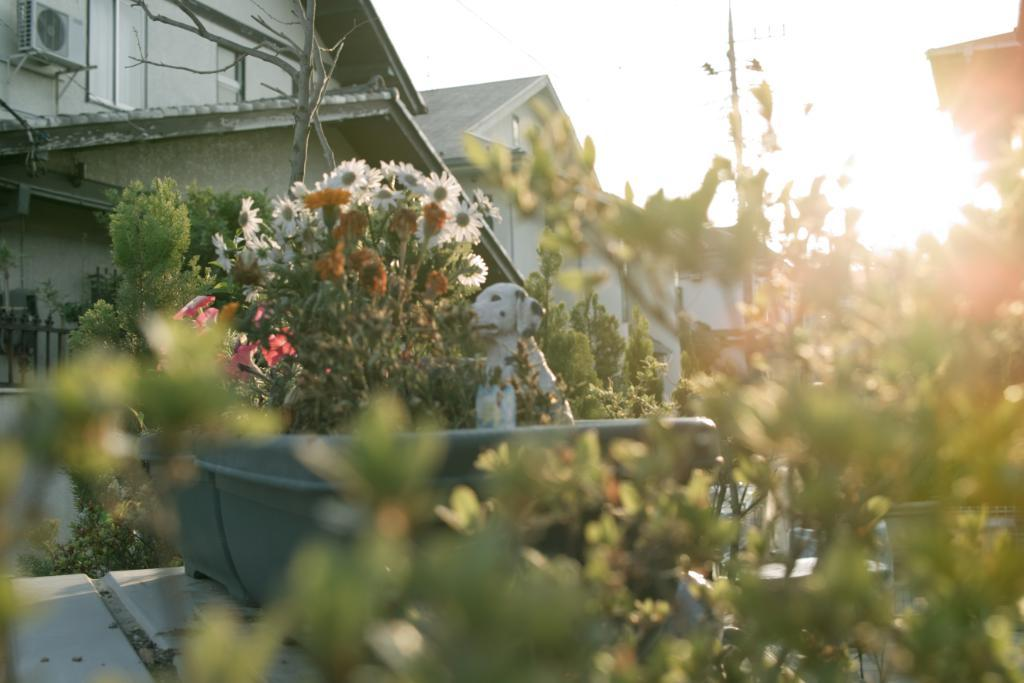What types of living organisms can be seen in the image? Plants and flowers are visible in the image. What is the color of the container in the image? The container in the image is green-colored. What object can be found in the front of the image? There is a white-colored toy in the front of the image. What can be seen in the background of the image? There is a tree and buildings in the background of the image. What type of texture can be seen on the toad in the image? There is no toad present in the image; it features plants, flowers, a green container, a white toy, a tree, and buildings in the background. 